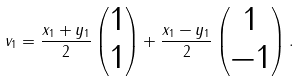<formula> <loc_0><loc_0><loc_500><loc_500>v _ { 1 } = \frac { x _ { 1 } + y _ { 1 } } { 2 } \begin{pmatrix} 1 \\ 1 \end{pmatrix} + \frac { x _ { 1 } - y _ { 1 } } { 2 } \begin{pmatrix} 1 \\ - 1 \end{pmatrix} .</formula> 